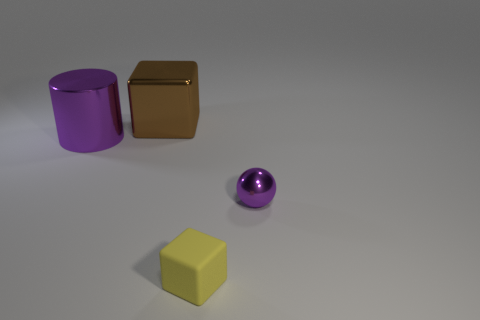Is there anything else that is the same shape as the big purple metal thing?
Provide a short and direct response. No. What number of other objects are the same material as the purple ball?
Provide a succinct answer. 2. What is the material of the large cube?
Keep it short and to the point. Metal. There is a block that is to the right of the big brown object; what is its size?
Your answer should be very brief. Small. What number of purple metal balls are on the left side of the large thing that is on the left side of the metal cube?
Keep it short and to the point. 0. Is the shape of the tiny thing left of the tiny purple metallic sphere the same as the purple metallic object on the left side of the small metal thing?
Your answer should be compact. No. How many objects are in front of the brown metal block and to the left of the rubber cube?
Keep it short and to the point. 1. Is there a small metallic sphere that has the same color as the large block?
Your answer should be very brief. No. The metallic object that is the same size as the shiny block is what shape?
Keep it short and to the point. Cylinder. Are there any big purple cylinders in front of the purple metallic cylinder?
Give a very brief answer. No. 